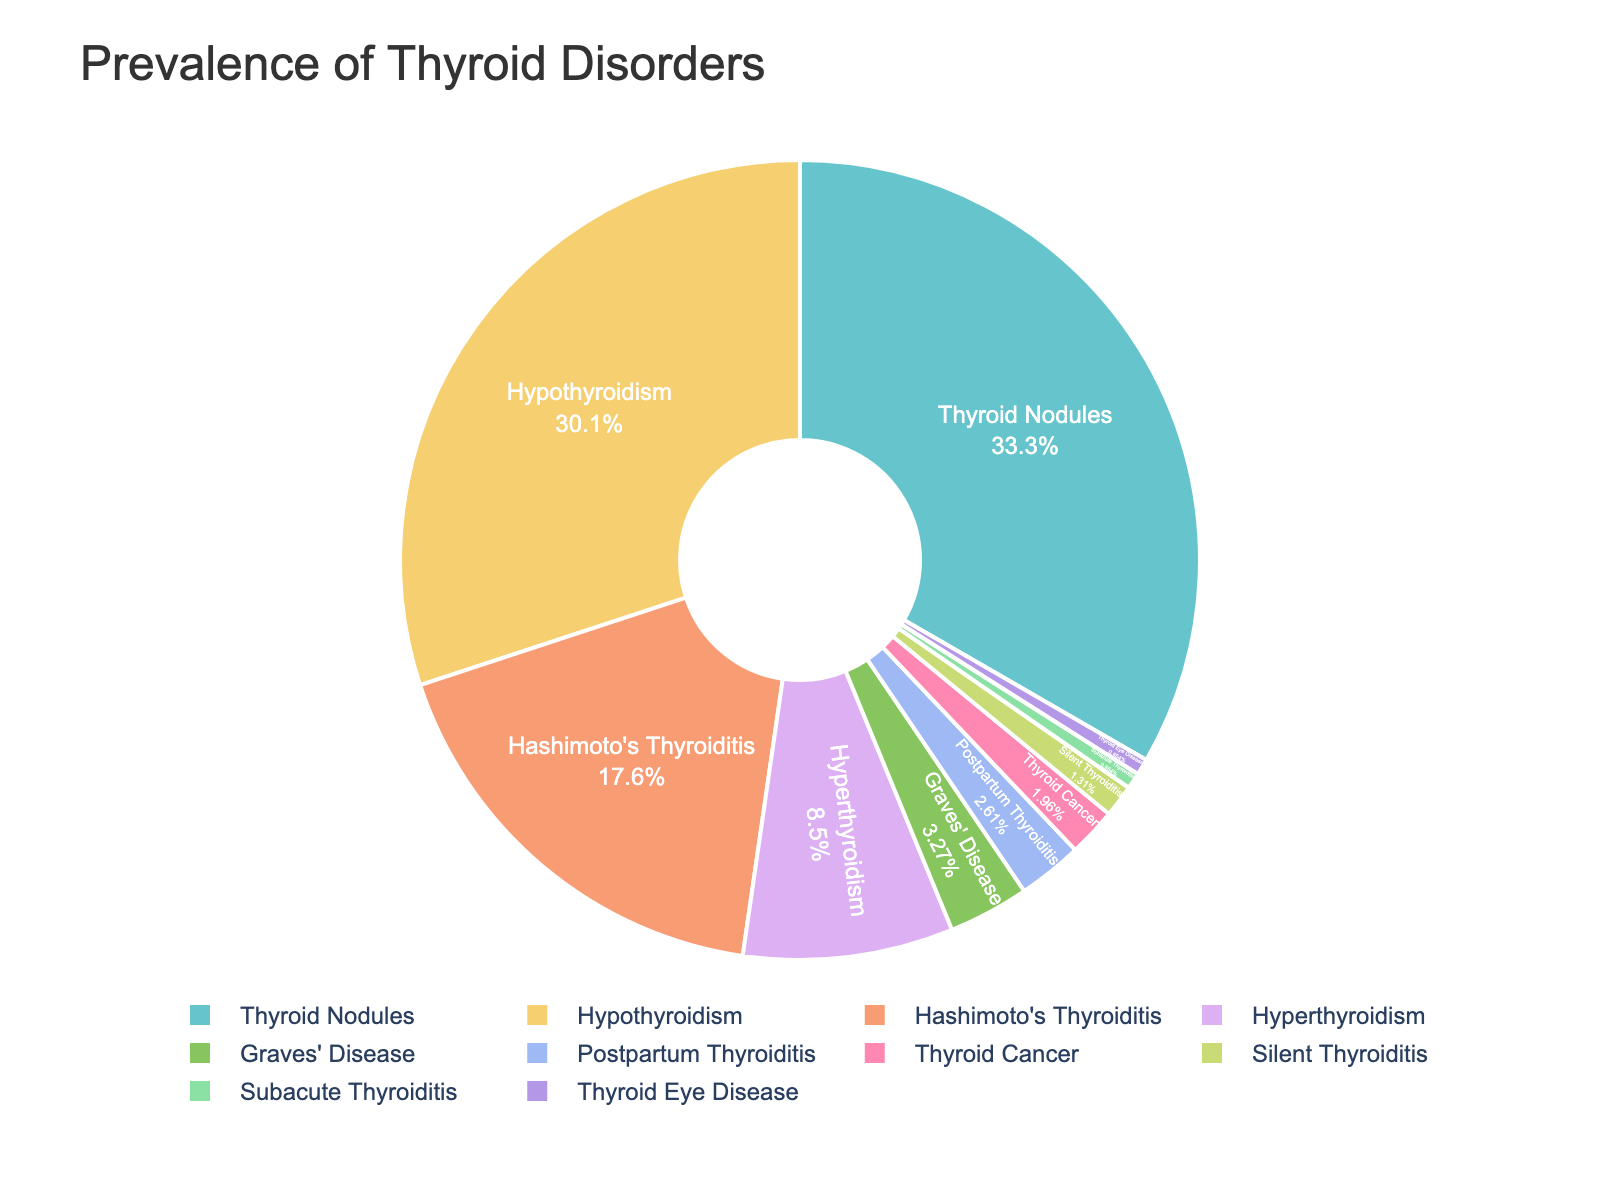Which thyroid disorder has the highest prevalence? To determine the thyroid disorder with the highest prevalence, look for the largest segment in the pie chart. The thyroid disorder corresponding to this segment is the one with the highest prevalence.
Answer: Thyroid Nodules What is the combined prevalence of Hypothyroidism and Hyperthyroidism? First, identify the prevalence percentages of Hypothyroidism and Hyperthyroidism from the pie chart. Hypothyroidism is 4.6% and Hyperthyroidism is 1.3%. Add these percentages together: 4.6% + 1.3% = 5.9%.
Answer: 5.9% Which thyroid disorder has a lower prevalence: Graves' Disease or Thyroid Cancer? Compare the sizes of the segments representing Graves' Disease and Thyroid Cancer. The smaller segment represents the disorder with the lower prevalence. Graves' Disease has a prevalence of 0.5% and Thyroid Cancer has a prevalence of 0.3%.
Answer: Thyroid Cancer What is the difference in prevalence between Hashimoto's Thyroiditis and Silent Thyroiditis? Find the prevalence percentages for Hashimoto's Thyroiditis (2.7%) and Silent Thyroiditis (0.2%). Subtract the prevalence of Silent Thyroiditis from that of Hashimoto's Thyroiditis: 2.7% - 0.2% = 2.5%.
Answer: 2.5% Which has a greater prevalence: Postpartum Thyroiditis or Subacute Thyroiditis? Look at the pie chart and compare the sizes of the segments representing Postpartum Thyroiditis and Subacute Thyroiditis. Postpartum Thyroiditis has a prevalence of 0.4% and Subacute Thyroiditis has a prevalence of 0.1%.
Answer: Postpartum Thyroiditis Calculate the average prevalence of the two least prevalent thyroid disorders. Determine the two least prevalent thyroid disorders from the pie chart, which are Subacute Thyroiditis (0.1%) and Thyroid Eye Disease (0.1%). Compute the average: (0.1% + 0.1%) / 2 = 0.1%.
Answer: 0.1% Which color represents Hypothyroidism in the pie chart? Identify the segment labeled "Hypothyroidism" in the pie chart, observe its color, and describe that color.
Answer: Varies (depends on the specific pie chart, commonly a pastel color) Which disorder has a higher prevalence: Thyroid Nodules or the combined total of Postpartum Thyroiditis and Subacute Thyroiditis? Calculate the combined total prevalence of Postpartum Thyroiditis (0.4%) and Subacute Thyroiditis (0.1%): 0.4% + 0.1% = 0.5%. Then compare this total with the prevalence of Thyroid Nodules (5.1%).
Answer: Thyroid Nodules What is the total prevalence of all disorders with at least 2% prevalence? Identify the disorders with prevalences of at least 2% from the pie chart: Hypothyroidism (4.6%), Hashimoto's Thyroiditis (2.7%), and Thyroid Nodules (5.1%). Add these together: 4.6% + 2.7% + 5.1% = 12.4%.
Answer: 12.4% 